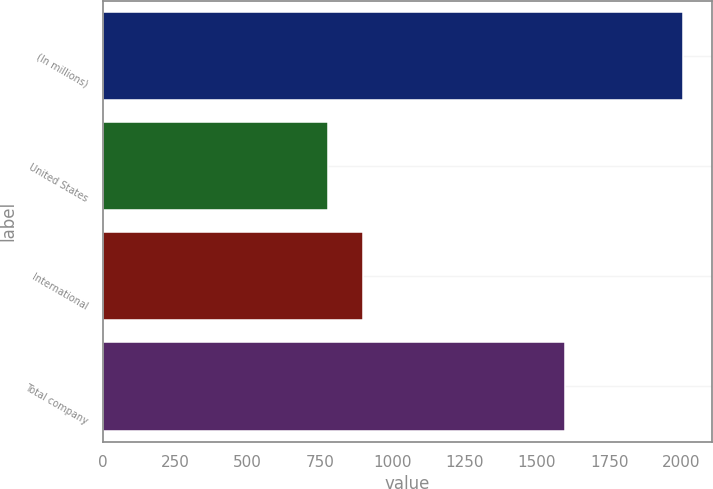Convert chart to OTSL. <chart><loc_0><loc_0><loc_500><loc_500><bar_chart><fcel>(In millions)<fcel>United States<fcel>International<fcel>Total company<nl><fcel>2006<fcel>777<fcel>899.9<fcel>1598<nl></chart> 